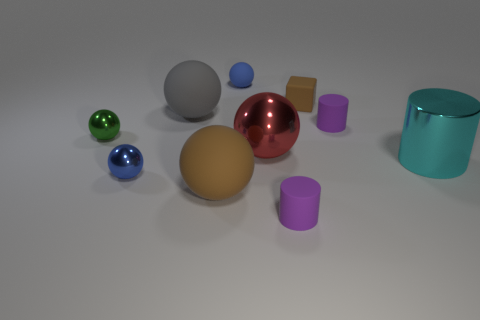Subtract all red spheres. How many spheres are left? 5 Subtract all tiny rubber balls. How many balls are left? 5 Subtract all gray spheres. Subtract all purple cubes. How many spheres are left? 5 Subtract all cylinders. How many objects are left? 7 Subtract 1 gray spheres. How many objects are left? 9 Subtract all red blocks. Subtract all big objects. How many objects are left? 6 Add 8 big gray balls. How many big gray balls are left? 9 Add 8 tiny cyan metallic cylinders. How many tiny cyan metallic cylinders exist? 8 